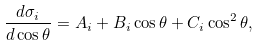Convert formula to latex. <formula><loc_0><loc_0><loc_500><loc_500>\frac { d \sigma _ { i } } { d \cos \theta } = A _ { i } + B _ { i } \cos \theta + C _ { i } \cos ^ { 2 } \theta ,</formula> 